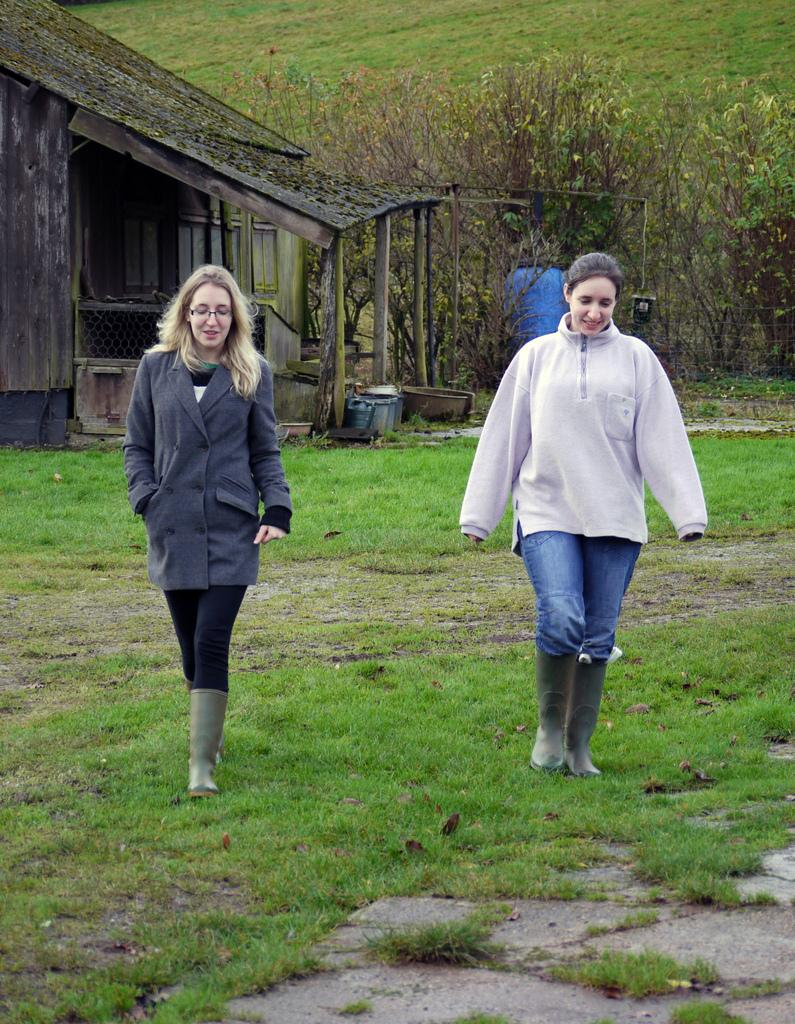What type of structure is visible in the image? There is a house in the image. What are the two people in the image doing? The two people in the image are walking. What is the terrain like in the image? There is a grassy land in the image. What type of vegetation can be seen in the image? There are many plants in the image. How many gloves can be seen on the rabbits in the image? There are no gloves or rabbits present in the image. 